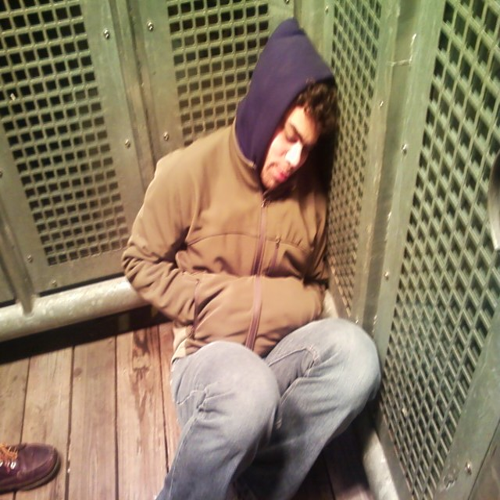Is there any specific detail in the image that indicates the time of day? Without visible windows or natural light, it's not possible to deduce the time of day from the image. The lack of context and absence of time indicators such as clocks means we can't accurately determine whether it's day or night. 